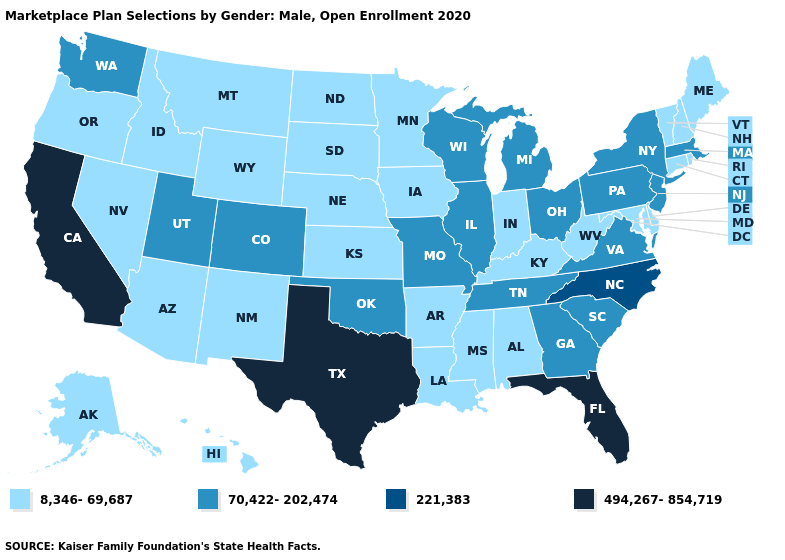Which states have the lowest value in the West?
Concise answer only. Alaska, Arizona, Hawaii, Idaho, Montana, Nevada, New Mexico, Oregon, Wyoming. Name the states that have a value in the range 221,383?
Concise answer only. North Carolina. Does Oklahoma have the same value as Utah?
Concise answer only. Yes. Which states hav the highest value in the South?
Short answer required. Florida, Texas. Which states hav the highest value in the Northeast?
Be succinct. Massachusetts, New Jersey, New York, Pennsylvania. What is the highest value in states that border Louisiana?
Quick response, please. 494,267-854,719. How many symbols are there in the legend?
Give a very brief answer. 4. Name the states that have a value in the range 70,422-202,474?
Concise answer only. Colorado, Georgia, Illinois, Massachusetts, Michigan, Missouri, New Jersey, New York, Ohio, Oklahoma, Pennsylvania, South Carolina, Tennessee, Utah, Virginia, Washington, Wisconsin. Does Idaho have the lowest value in the USA?
Write a very short answer. Yes. What is the value of Wyoming?
Short answer required. 8,346-69,687. Does the first symbol in the legend represent the smallest category?
Give a very brief answer. Yes. Name the states that have a value in the range 494,267-854,719?
Keep it brief. California, Florida, Texas. Name the states that have a value in the range 70,422-202,474?
Keep it brief. Colorado, Georgia, Illinois, Massachusetts, Michigan, Missouri, New Jersey, New York, Ohio, Oklahoma, Pennsylvania, South Carolina, Tennessee, Utah, Virginia, Washington, Wisconsin. Which states have the highest value in the USA?
Give a very brief answer. California, Florida, Texas. Does Maryland have the highest value in the South?
Keep it brief. No. 